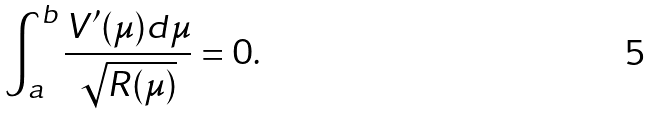<formula> <loc_0><loc_0><loc_500><loc_500>\int _ { a } ^ { b } \frac { V ^ { \prime } ( \mu ) d \mu } { \sqrt { R ( \mu ) } } = 0 .</formula> 